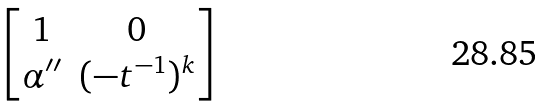<formula> <loc_0><loc_0><loc_500><loc_500>\begin{bmatrix} 1 & 0 \\ \alpha ^ { \prime \prime } & ( - t ^ { - 1 } ) ^ { k } \end{bmatrix}</formula> 